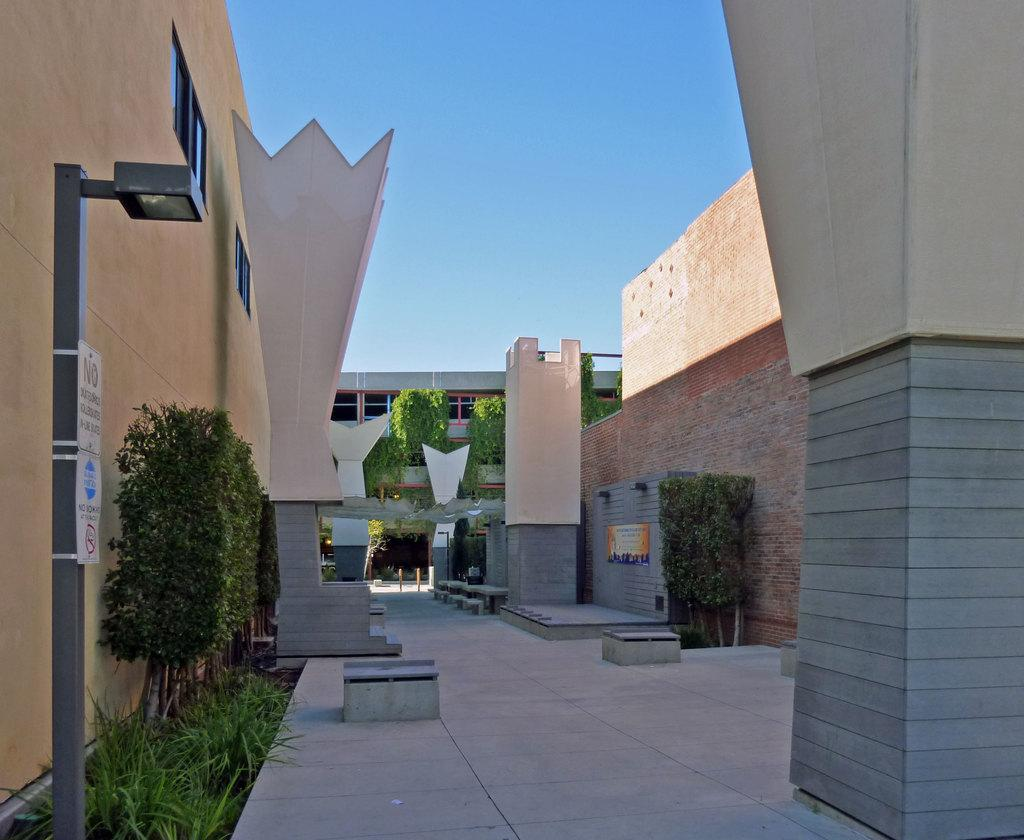<image>
Describe the image concisely. an inner courtyard of a building with signs saying NO 